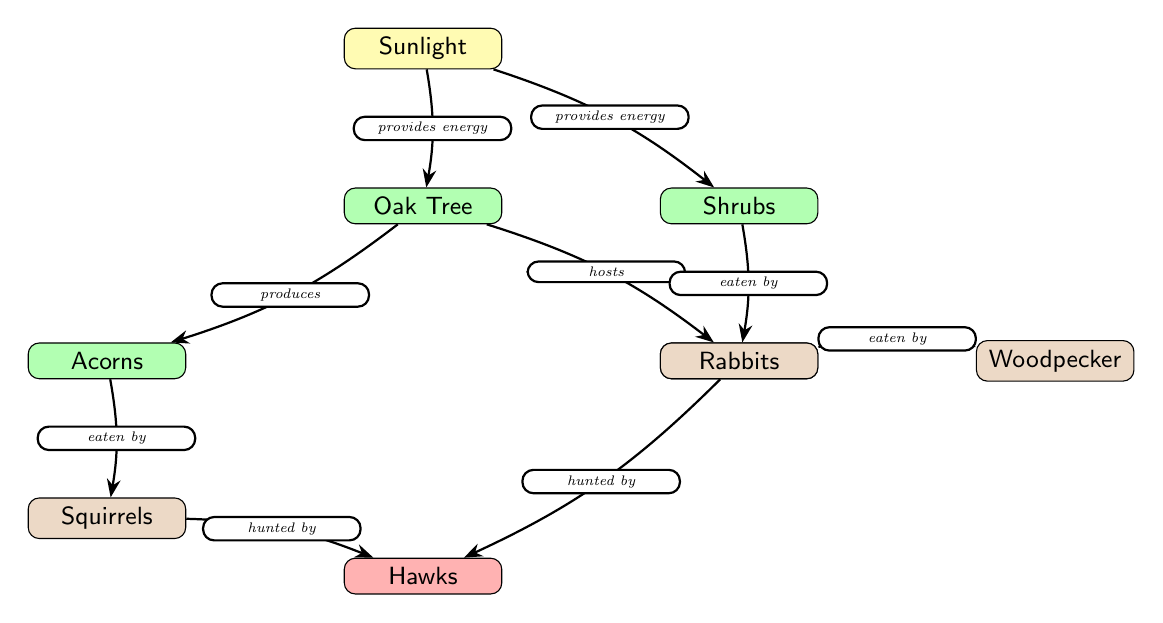What is the source of energy in this food chain? The diagram indicates that Sunlight is the source of energy, as it is the topmost node that leads to the plants below.
Answer: Sunlight Which plant produces acorns? The Oak Tree node directly connects to the Acorns node, indicating that it is the plant that produces acorns.
Answer: Oak Tree How many types of animals are shown in the diagram? The animals labeled in the diagram include Squirrels, Insects, Woodpecker, Rabbits, and Hawks, making a total of five distinct animal types.
Answer: 5 What do rabbits eat according to this diagram? The diagram shows that Rabbits eat Shrubs, as the edge from Shrubs to Rabbits indicates this relationship.
Answer: Shrubs Which animal is a predator in the food chain? The Hawks node has edges connecting to both Squirrels and Rabbits, demonstrating that they hunt these animals, thereby categorizing them as predators.
Answer: Hawks What is the relationship between insects and woodpeckers? The diagram states that Woodpeckers eat Insects, represented by the directed edge from Insects to Woodpeckers in the food chain.
Answer: eaten by Which two plants are connected to the sunlight? The diagram shows connections from Sunlight to both the Oak Tree and Shrubs, indicating these two plants receive energy from sunlight.
Answer: Oak Tree and Shrubs How are squirrels connected to hawks? The diagram illustrates that both Squirrels and Rabbits are hunted by Hawks, creating a connection between these animals in the food chain.
Answer: hunted by What does the Oak Tree host? According to the diagram, the Oak Tree hosts Insects, as indicated by the direct connection labeled "hosts" from Oak Tree to Insects.
Answer: Insects 